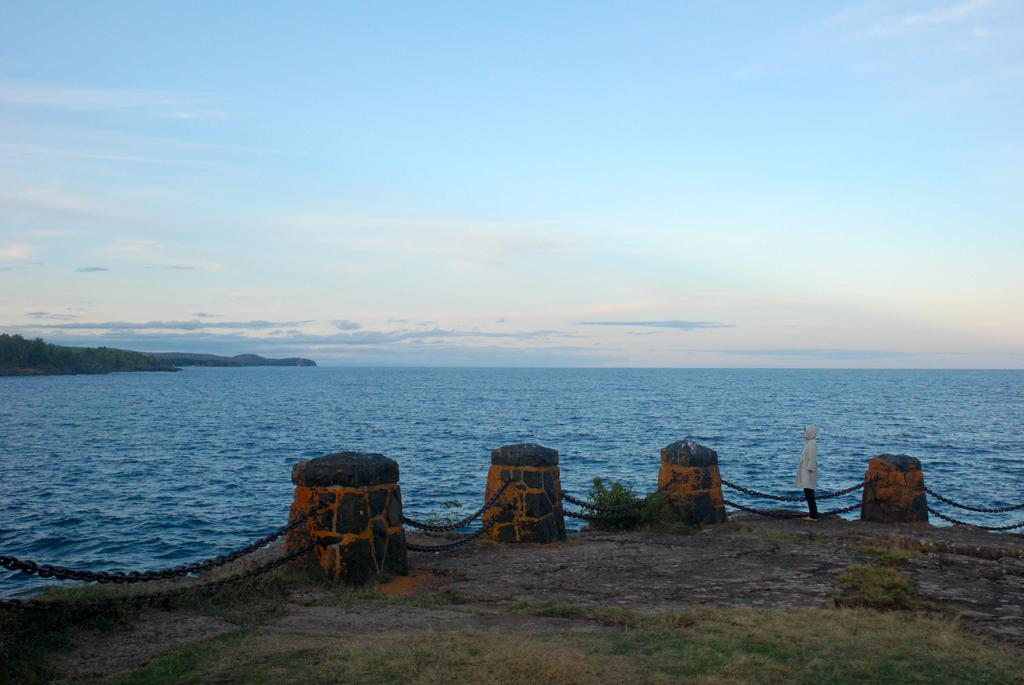What is the main subject of the image? There is a person standing in the image. Can you describe the person's attire? The person is wearing clothes. What type of natural environment can be seen in the image? There is sea, grass, hills, and stones visible in the image. How would you describe the sky in the image? The sky is cloudy and pale blue. Are there any man-made structures in the image? Yes, there is a pillar and metal chains in the image. How many bikes are parked near the wall in the image? There is no wall or bikes present in the image. What time does the clock show in the image? There is no clock present in the image. 